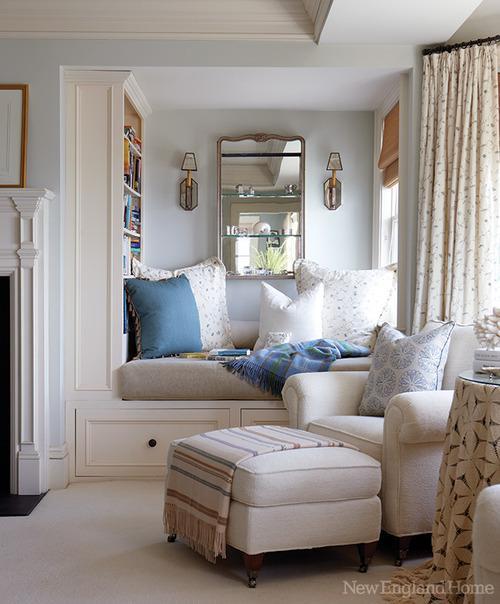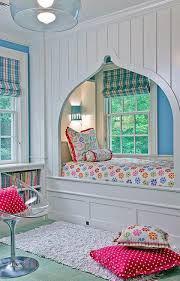The first image is the image on the left, the second image is the image on the right. Considering the images on both sides, is "In at least one image there is a single knitted pillow with a afghan on top of a sofa chair." valid? Answer yes or no. No. The first image is the image on the left, the second image is the image on the right. Assess this claim about the two images: "One image includes a square pale pillow with a horizontal row of at least three buttons, and the other image features multiple pillows on a white couch, including pillows with all-over picture prints.". Correct or not? Answer yes or no. No. 